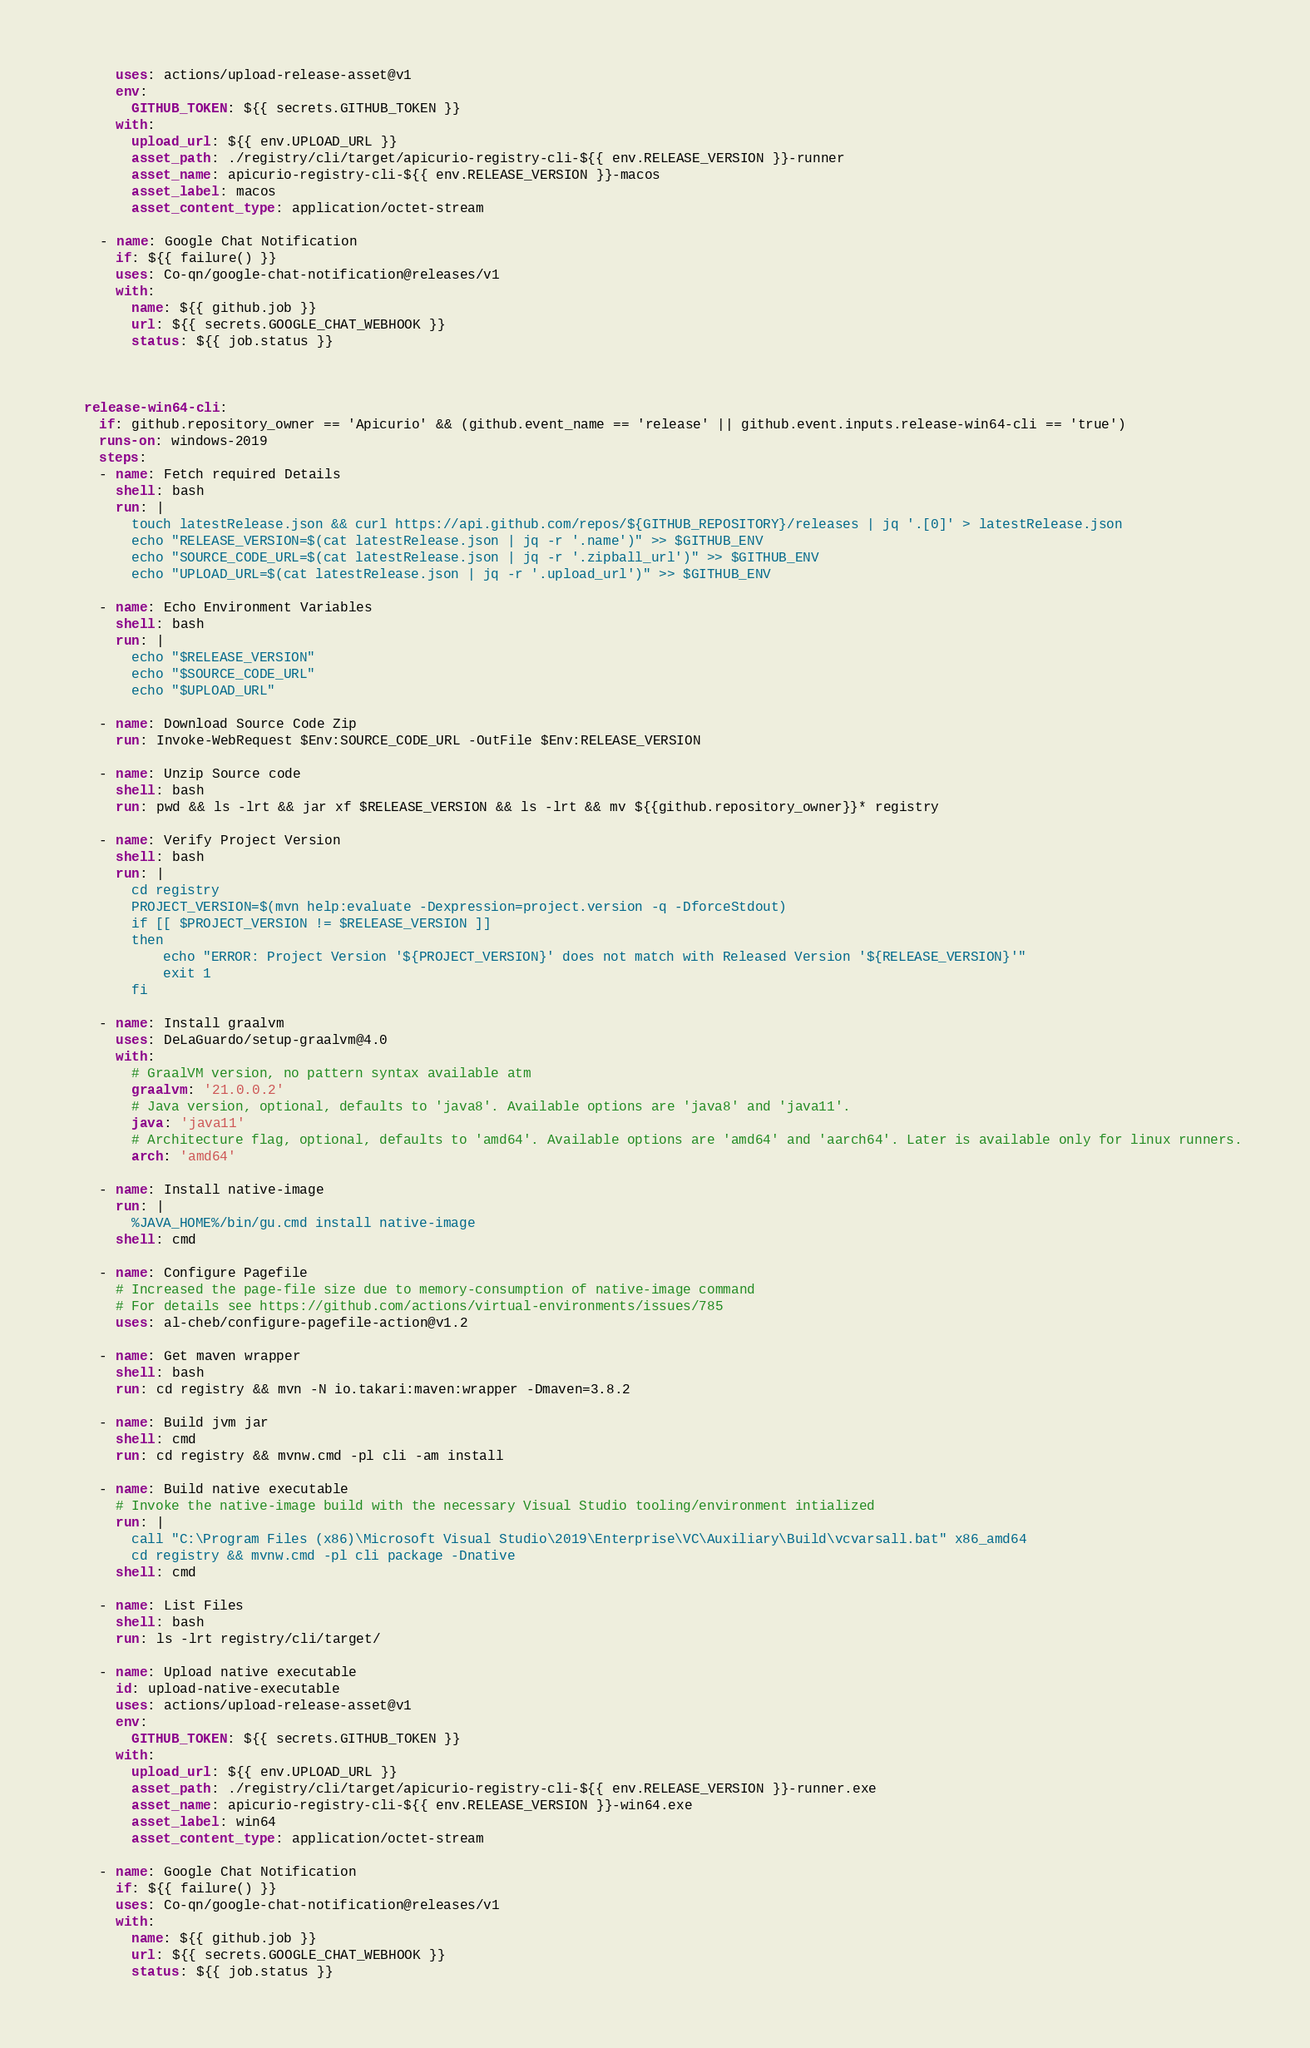<code> <loc_0><loc_0><loc_500><loc_500><_YAML_>      uses: actions/upload-release-asset@v1
      env:
        GITHUB_TOKEN: ${{ secrets.GITHUB_TOKEN }}
      with:
        upload_url: ${{ env.UPLOAD_URL }}
        asset_path: ./registry/cli/target/apicurio-registry-cli-${{ env.RELEASE_VERSION }}-runner
        asset_name: apicurio-registry-cli-${{ env.RELEASE_VERSION }}-macos
        asset_label: macos
        asset_content_type: application/octet-stream

    - name: Google Chat Notification
      if: ${{ failure() }}
      uses: Co-qn/google-chat-notification@releases/v1
      with:
        name: ${{ github.job }}
        url: ${{ secrets.GOOGLE_CHAT_WEBHOOK }}
        status: ${{ job.status }}



  release-win64-cli:
    if: github.repository_owner == 'Apicurio' && (github.event_name == 'release' || github.event.inputs.release-win64-cli == 'true')
    runs-on: windows-2019
    steps:
    - name: Fetch required Details
      shell: bash
      run: |
        touch latestRelease.json && curl https://api.github.com/repos/${GITHUB_REPOSITORY}/releases | jq '.[0]' > latestRelease.json
        echo "RELEASE_VERSION=$(cat latestRelease.json | jq -r '.name')" >> $GITHUB_ENV
        echo "SOURCE_CODE_URL=$(cat latestRelease.json | jq -r '.zipball_url')" >> $GITHUB_ENV
        echo "UPLOAD_URL=$(cat latestRelease.json | jq -r '.upload_url')" >> $GITHUB_ENV
          
    - name: Echo Environment Variables
      shell: bash
      run: |
        echo "$RELEASE_VERSION"
        echo "$SOURCE_CODE_URL"
        echo "$UPLOAD_URL"

    - name: Download Source Code Zip
      run: Invoke-WebRequest $Env:SOURCE_CODE_URL -OutFile $Env:RELEASE_VERSION
      
    - name: Unzip Source code
      shell: bash
      run: pwd && ls -lrt && jar xf $RELEASE_VERSION && ls -lrt && mv ${{github.repository_owner}}* registry
        
    - name: Verify Project Version
      shell: bash
      run: |
        cd registry
        PROJECT_VERSION=$(mvn help:evaluate -Dexpression=project.version -q -DforceStdout)
        if [[ $PROJECT_VERSION != $RELEASE_VERSION ]]
        then
            echo "ERROR: Project Version '${PROJECT_VERSION}' does not match with Released Version '${RELEASE_VERSION}'"
            exit 1	  
        fi

    - name: Install graalvm
      uses: DeLaGuardo/setup-graalvm@4.0
      with:
        # GraalVM version, no pattern syntax available atm
        graalvm: '21.0.0.2'
        # Java version, optional, defaults to 'java8'. Available options are 'java8' and 'java11'.
        java: 'java11'
        # Architecture flag, optional, defaults to 'amd64'. Available options are 'amd64' and 'aarch64'. Later is available only for linux runners.
        arch: 'amd64'

    - name: Install native-image
      run: |
        %JAVA_HOME%/bin/gu.cmd install native-image
      shell: cmd

    - name: Configure Pagefile
      # Increased the page-file size due to memory-consumption of native-image command
      # For details see https://github.com/actions/virtual-environments/issues/785
      uses: al-cheb/configure-pagefile-action@v1.2

    - name: Get maven wrapper
      shell: bash
      run: cd registry && mvn -N io.takari:maven:wrapper -Dmaven=3.8.2

    - name: Build jvm jar
      shell: cmd
      run: cd registry && mvnw.cmd -pl cli -am install

    - name: Build native executable
      # Invoke the native-image build with the necessary Visual Studio tooling/environment intialized
      run: |
        call "C:\Program Files (x86)\Microsoft Visual Studio\2019\Enterprise\VC\Auxiliary\Build\vcvarsall.bat" x86_amd64
        cd registry && mvnw.cmd -pl cli package -Dnative
      shell: cmd
      
    - name: List Files
      shell: bash
      run: ls -lrt registry/cli/target/

    - name: Upload native executable
      id: upload-native-executable
      uses: actions/upload-release-asset@v1
      env:
        GITHUB_TOKEN: ${{ secrets.GITHUB_TOKEN }}
      with:
        upload_url: ${{ env.UPLOAD_URL }}
        asset_path: ./registry/cli/target/apicurio-registry-cli-${{ env.RELEASE_VERSION }}-runner.exe
        asset_name: apicurio-registry-cli-${{ env.RELEASE_VERSION }}-win64.exe
        asset_label: win64
        asset_content_type: application/octet-stream

    - name: Google Chat Notification
      if: ${{ failure() }}
      uses: Co-qn/google-chat-notification@releases/v1
      with:
        name: ${{ github.job }}
        url: ${{ secrets.GOOGLE_CHAT_WEBHOOK }}
        status: ${{ job.status }}</code> 